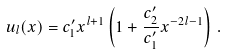<formula> <loc_0><loc_0><loc_500><loc_500>u _ { l } ( x ) = c ^ { \prime } _ { 1 } x ^ { l + 1 } \left ( 1 + \frac { c ^ { \prime } _ { 2 } } { c ^ { \prime } _ { 1 } } x ^ { - 2 l - 1 } \right ) \, .</formula> 